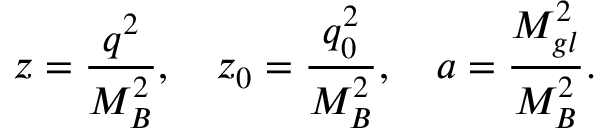<formula> <loc_0><loc_0><loc_500><loc_500>z = { \frac { q ^ { 2 } } { M _ { B } ^ { 2 } } } , \quad z _ { 0 } = { \frac { q _ { 0 } ^ { 2 } } { M _ { B } ^ { 2 } } } , \quad a = { \frac { M _ { g l } ^ { 2 } } { M _ { B } ^ { 2 } } } .</formula> 